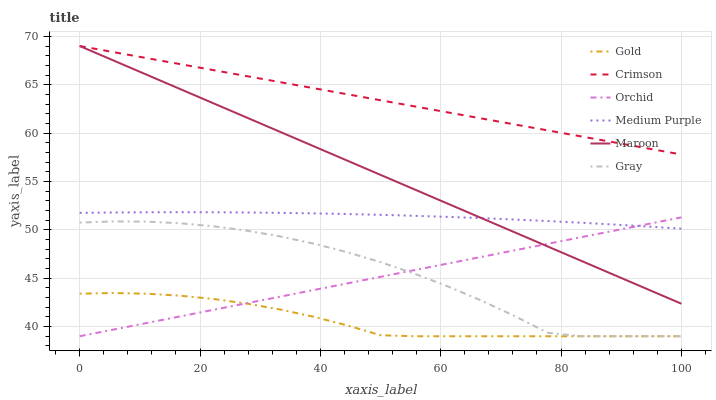Does Gold have the minimum area under the curve?
Answer yes or no. Yes. Does Crimson have the maximum area under the curve?
Answer yes or no. Yes. Does Maroon have the minimum area under the curve?
Answer yes or no. No. Does Maroon have the maximum area under the curve?
Answer yes or no. No. Is Maroon the smoothest?
Answer yes or no. Yes. Is Gray the roughest?
Answer yes or no. Yes. Is Gold the smoothest?
Answer yes or no. No. Is Gold the roughest?
Answer yes or no. No. Does Gray have the lowest value?
Answer yes or no. Yes. Does Maroon have the lowest value?
Answer yes or no. No. Does Crimson have the highest value?
Answer yes or no. Yes. Does Gold have the highest value?
Answer yes or no. No. Is Orchid less than Crimson?
Answer yes or no. Yes. Is Crimson greater than Orchid?
Answer yes or no. Yes. Does Gold intersect Orchid?
Answer yes or no. Yes. Is Gold less than Orchid?
Answer yes or no. No. Is Gold greater than Orchid?
Answer yes or no. No. Does Orchid intersect Crimson?
Answer yes or no. No. 